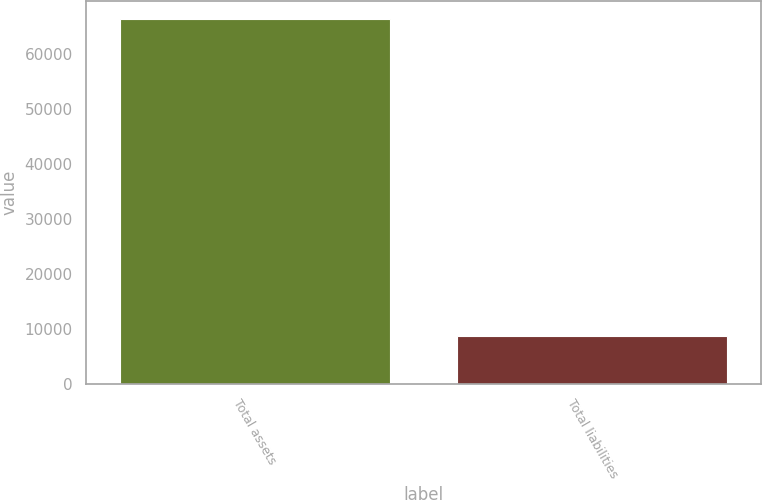<chart> <loc_0><loc_0><loc_500><loc_500><bar_chart><fcel>Total assets<fcel>Total liabilities<nl><fcel>66428<fcel>8625<nl></chart> 